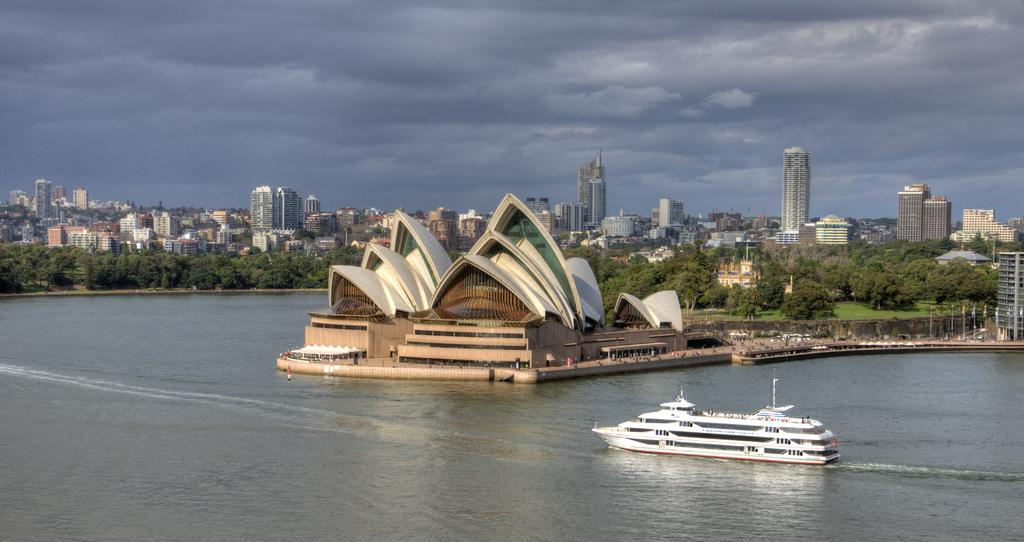What type of natural body of water is visible in the image? There is an ocean in the image. What is floating on the ocean in the image? There is a boat in the ocean. What type of man-made structure can be seen in the image? There is a building on the path in the image. How many buildings can be seen in the image? There are additional buildings visible in the image, along with the building on the path. What type of vegetation is present in the image? Trees and plants are visible in the image. What type of engine is powering the boat in the image? There is no information about the engine of the boat in the image, as it is not mentioned in the provided facts. 